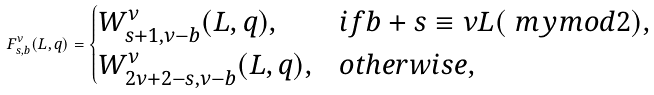Convert formula to latex. <formula><loc_0><loc_0><loc_500><loc_500>F _ { s , b } ^ { \nu } ( L , q ) = \begin{cases} W _ { s + 1 , \nu - b } ^ { \nu } ( L , q ) , & i f b + s \equiv \nu L ( \ m y m o d 2 ) , \\ W _ { 2 \nu + 2 - s , \nu - b } ^ { \nu } ( L , q ) , & o t h e r w i s e , \end{cases}</formula> 